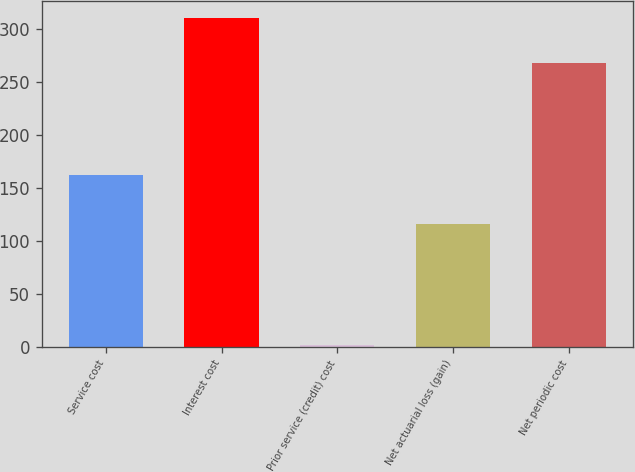<chart> <loc_0><loc_0><loc_500><loc_500><bar_chart><fcel>Service cost<fcel>Interest cost<fcel>Prior service (credit) cost<fcel>Net actuarial loss (gain)<fcel>Net periodic cost<nl><fcel>162<fcel>311<fcel>2<fcel>116<fcel>268<nl></chart> 